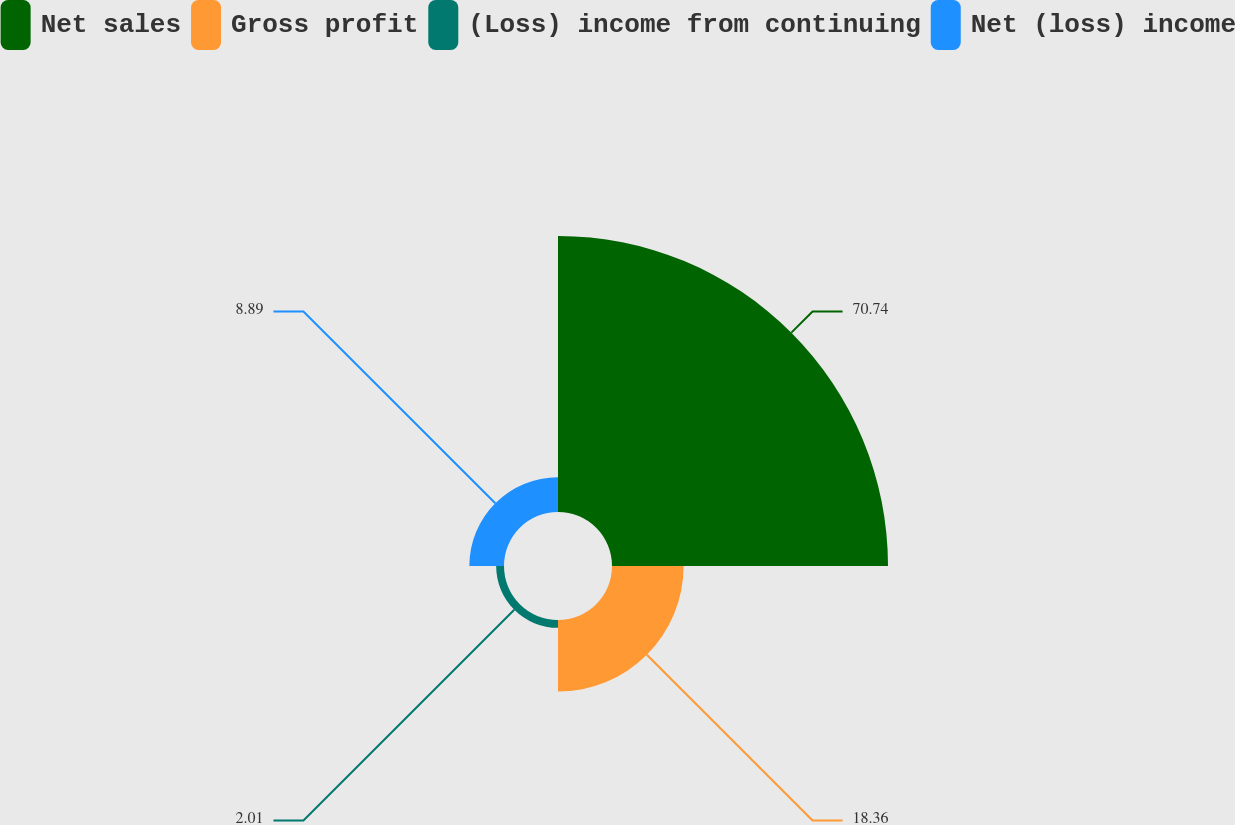Convert chart. <chart><loc_0><loc_0><loc_500><loc_500><pie_chart><fcel>Net sales<fcel>Gross profit<fcel>(Loss) income from continuing<fcel>Net (loss) income<nl><fcel>70.75%<fcel>18.36%<fcel>2.01%<fcel>8.89%<nl></chart> 